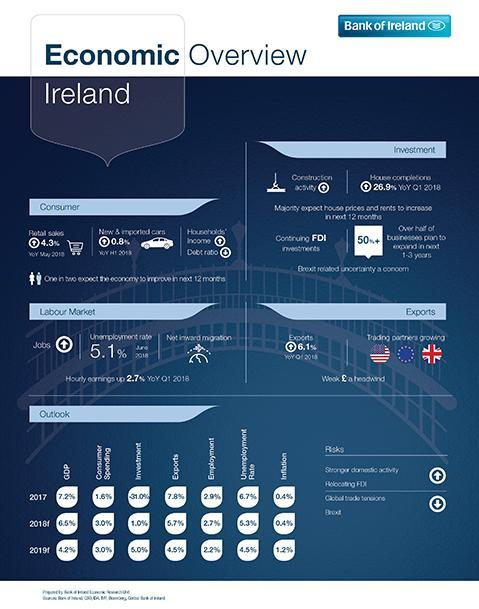What is the difference between the GDP growth of Ireland in 2017 and 2018?
Answer the question with a short phrase. -0.7% 